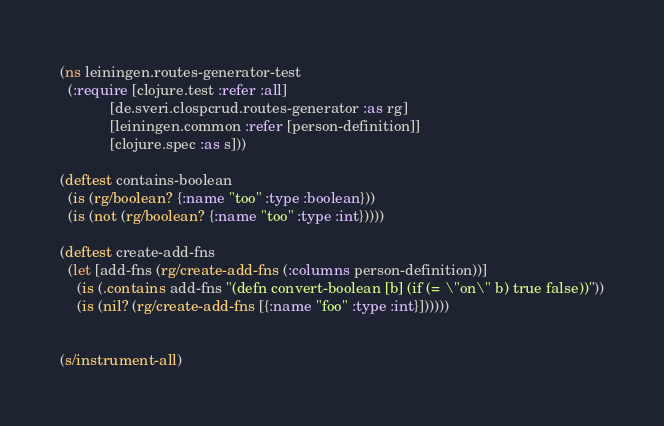<code> <loc_0><loc_0><loc_500><loc_500><_Clojure_>(ns leiningen.routes-generator-test
  (:require [clojure.test :refer :all]
            [de.sveri.clospcrud.routes-generator :as rg]
            [leiningen.common :refer [person-definition]]
            [clojure.spec :as s]))

(deftest contains-boolean
  (is (rg/boolean? {:name "too" :type :boolean}))
  (is (not (rg/boolean? {:name "too" :type :int}))))

(deftest create-add-fns
  (let [add-fns (rg/create-add-fns (:columns person-definition))]
    (is (.contains add-fns "(defn convert-boolean [b] (if (= \"on\" b) true false))"))
    (is (nil? (rg/create-add-fns [{:name "foo" :type :int}])))))


(s/instrument-all)</code> 